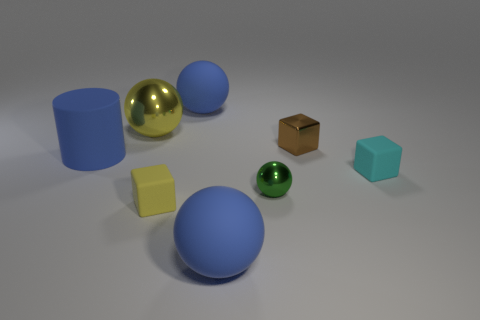Is the number of yellow spheres less than the number of gray matte blocks?
Your response must be concise. No. Is there another blue sphere made of the same material as the tiny sphere?
Give a very brief answer. No. There is a small thing to the right of the brown metal cube; what shape is it?
Provide a succinct answer. Cube. There is a tiny object in front of the tiny green object; is it the same color as the large metallic object?
Your answer should be very brief. Yes. Are there fewer big yellow things right of the yellow metallic ball than blue rubber cylinders?
Your answer should be compact. Yes. The tiny block that is made of the same material as the tiny yellow thing is what color?
Keep it short and to the point. Cyan. What size is the yellow thing to the left of the yellow block?
Your answer should be compact. Large. Are the cylinder and the green ball made of the same material?
Your answer should be compact. No. Is there a big object in front of the large matte sphere that is on the left side of the big blue matte sphere that is in front of the cyan cube?
Ensure brevity in your answer.  Yes. The small metal block is what color?
Provide a succinct answer. Brown. 